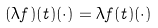Convert formula to latex. <formula><loc_0><loc_0><loc_500><loc_500>( \lambda f ) ( t ) ( \cdot ) = \lambda f ( t ) ( \cdot )</formula> 